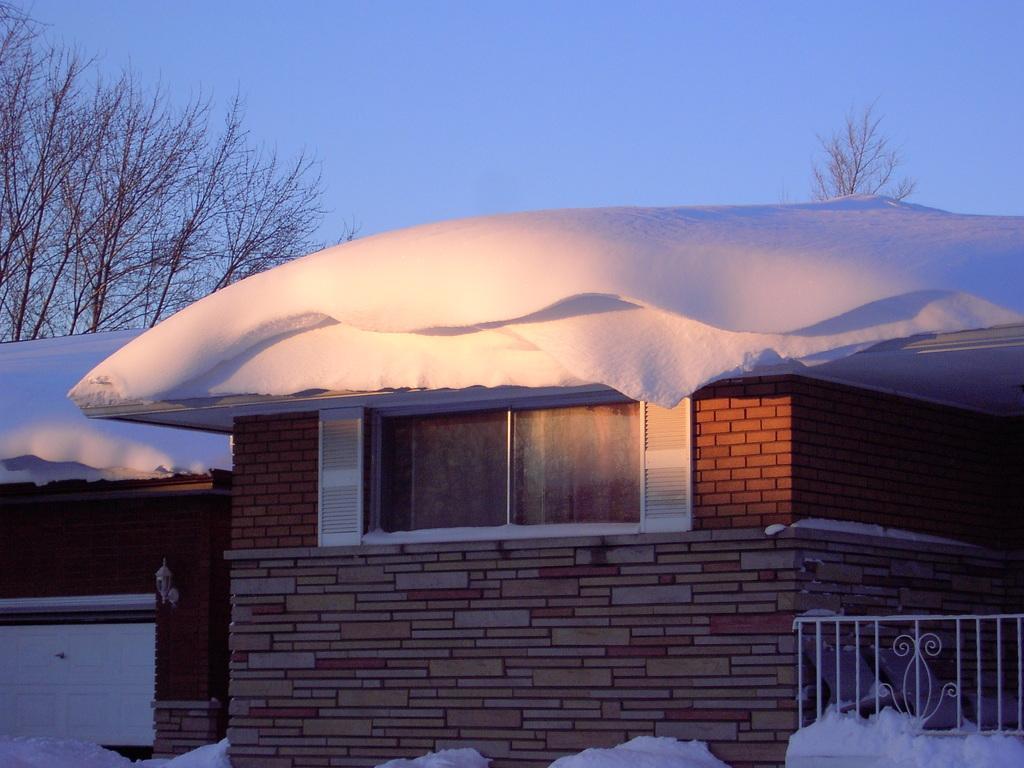How would you summarize this image in a sentence or two? In this picture we can see few houses, trees and snow, at the right bottom of the image we can see few metal rods. 